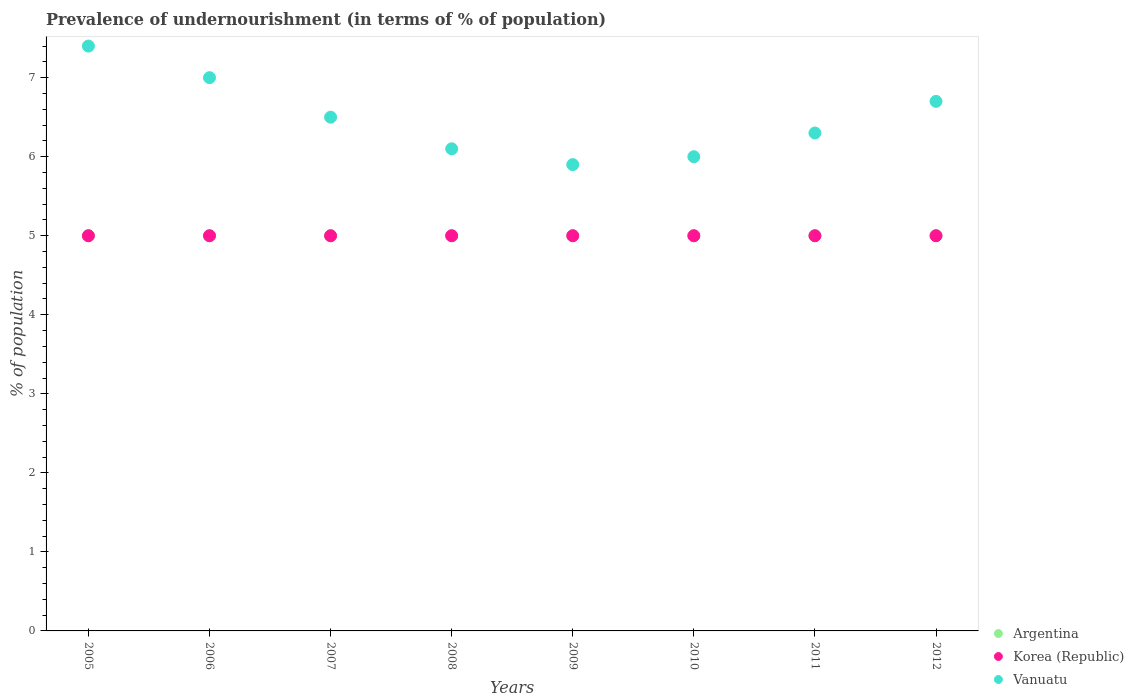How many different coloured dotlines are there?
Keep it short and to the point. 3. What is the percentage of undernourished population in Korea (Republic) in 2008?
Provide a short and direct response. 5. Across all years, what is the maximum percentage of undernourished population in Vanuatu?
Ensure brevity in your answer.  7.4. Across all years, what is the minimum percentage of undernourished population in Korea (Republic)?
Offer a very short reply. 5. In which year was the percentage of undernourished population in Argentina maximum?
Provide a short and direct response. 2005. What is the total percentage of undernourished population in Korea (Republic) in the graph?
Provide a short and direct response. 40. What is the difference between the percentage of undernourished population in Korea (Republic) in 2008 and that in 2012?
Give a very brief answer. 0. What is the difference between the percentage of undernourished population in Argentina in 2006 and the percentage of undernourished population in Vanuatu in 2011?
Keep it short and to the point. -1.3. What is the average percentage of undernourished population in Vanuatu per year?
Your answer should be very brief. 6.49. In the year 2005, what is the difference between the percentage of undernourished population in Vanuatu and percentage of undernourished population in Argentina?
Your response must be concise. 2.4. In how many years, is the percentage of undernourished population in Argentina greater than 5.4 %?
Your answer should be very brief. 0. What is the ratio of the percentage of undernourished population in Vanuatu in 2006 to that in 2011?
Provide a short and direct response. 1.11. Is the percentage of undernourished population in Vanuatu in 2008 less than that in 2009?
Provide a short and direct response. No. Is the difference between the percentage of undernourished population in Vanuatu in 2006 and 2007 greater than the difference between the percentage of undernourished population in Argentina in 2006 and 2007?
Your answer should be compact. Yes. What is the difference between the highest and the second highest percentage of undernourished population in Vanuatu?
Offer a very short reply. 0.4. In how many years, is the percentage of undernourished population in Vanuatu greater than the average percentage of undernourished population in Vanuatu taken over all years?
Your answer should be compact. 4. Is the sum of the percentage of undernourished population in Korea (Republic) in 2006 and 2007 greater than the maximum percentage of undernourished population in Vanuatu across all years?
Make the answer very short. Yes. Is it the case that in every year, the sum of the percentage of undernourished population in Vanuatu and percentage of undernourished population in Argentina  is greater than the percentage of undernourished population in Korea (Republic)?
Provide a short and direct response. Yes. Is the percentage of undernourished population in Argentina strictly greater than the percentage of undernourished population in Vanuatu over the years?
Ensure brevity in your answer.  No. How many years are there in the graph?
Make the answer very short. 8. Where does the legend appear in the graph?
Make the answer very short. Bottom right. How many legend labels are there?
Your answer should be compact. 3. How are the legend labels stacked?
Ensure brevity in your answer.  Vertical. What is the title of the graph?
Offer a terse response. Prevalence of undernourishment (in terms of % of population). What is the label or title of the Y-axis?
Provide a succinct answer. % of population. What is the % of population of Vanuatu in 2005?
Provide a succinct answer. 7.4. What is the % of population in Argentina in 2006?
Your answer should be compact. 5. What is the % of population of Korea (Republic) in 2006?
Give a very brief answer. 5. What is the % of population in Argentina in 2007?
Provide a succinct answer. 5. What is the % of population in Korea (Republic) in 2007?
Offer a very short reply. 5. What is the % of population of Argentina in 2008?
Give a very brief answer. 5. What is the % of population of Korea (Republic) in 2008?
Offer a terse response. 5. What is the % of population of Vanuatu in 2008?
Offer a very short reply. 6.1. What is the % of population in Vanuatu in 2009?
Offer a terse response. 5.9. What is the % of population in Argentina in 2010?
Your answer should be compact. 5. What is the % of population of Korea (Republic) in 2011?
Offer a very short reply. 5. Across all years, what is the maximum % of population of Korea (Republic)?
Your answer should be compact. 5. What is the total % of population of Korea (Republic) in the graph?
Provide a short and direct response. 40. What is the total % of population of Vanuatu in the graph?
Give a very brief answer. 51.9. What is the difference between the % of population of Korea (Republic) in 2005 and that in 2006?
Provide a short and direct response. 0. What is the difference between the % of population in Korea (Republic) in 2005 and that in 2008?
Your answer should be compact. 0. What is the difference between the % of population of Vanuatu in 2005 and that in 2008?
Your answer should be compact. 1.3. What is the difference between the % of population in Argentina in 2005 and that in 2009?
Offer a terse response. 0. What is the difference between the % of population in Korea (Republic) in 2005 and that in 2010?
Your answer should be very brief. 0. What is the difference between the % of population of Vanuatu in 2005 and that in 2010?
Offer a very short reply. 1.4. What is the difference between the % of population of Argentina in 2005 and that in 2011?
Ensure brevity in your answer.  0. What is the difference between the % of population in Korea (Republic) in 2005 and that in 2011?
Provide a succinct answer. 0. What is the difference between the % of population of Vanuatu in 2005 and that in 2011?
Your answer should be compact. 1.1. What is the difference between the % of population of Korea (Republic) in 2005 and that in 2012?
Your answer should be compact. 0. What is the difference between the % of population in Vanuatu in 2005 and that in 2012?
Your response must be concise. 0.7. What is the difference between the % of population in Argentina in 2006 and that in 2007?
Your answer should be compact. 0. What is the difference between the % of population of Korea (Republic) in 2006 and that in 2007?
Offer a very short reply. 0. What is the difference between the % of population in Vanuatu in 2006 and that in 2009?
Offer a very short reply. 1.1. What is the difference between the % of population of Argentina in 2006 and that in 2010?
Make the answer very short. 0. What is the difference between the % of population in Argentina in 2006 and that in 2011?
Make the answer very short. 0. What is the difference between the % of population in Vanuatu in 2006 and that in 2011?
Give a very brief answer. 0.7. What is the difference between the % of population of Argentina in 2006 and that in 2012?
Your response must be concise. 0. What is the difference between the % of population in Vanuatu in 2006 and that in 2012?
Offer a very short reply. 0.3. What is the difference between the % of population of Argentina in 2007 and that in 2009?
Give a very brief answer. 0. What is the difference between the % of population of Vanuatu in 2007 and that in 2009?
Give a very brief answer. 0.6. What is the difference between the % of population of Korea (Republic) in 2007 and that in 2010?
Provide a short and direct response. 0. What is the difference between the % of population in Vanuatu in 2007 and that in 2010?
Provide a short and direct response. 0.5. What is the difference between the % of population in Argentina in 2007 and that in 2011?
Make the answer very short. 0. What is the difference between the % of population in Korea (Republic) in 2007 and that in 2011?
Your answer should be compact. 0. What is the difference between the % of population of Korea (Republic) in 2007 and that in 2012?
Make the answer very short. 0. What is the difference between the % of population of Vanuatu in 2007 and that in 2012?
Offer a terse response. -0.2. What is the difference between the % of population in Argentina in 2008 and that in 2009?
Keep it short and to the point. 0. What is the difference between the % of population in Vanuatu in 2008 and that in 2009?
Ensure brevity in your answer.  0.2. What is the difference between the % of population in Argentina in 2008 and that in 2010?
Make the answer very short. 0. What is the difference between the % of population in Vanuatu in 2008 and that in 2010?
Keep it short and to the point. 0.1. What is the difference between the % of population in Korea (Republic) in 2008 and that in 2011?
Give a very brief answer. 0. What is the difference between the % of population of Vanuatu in 2008 and that in 2011?
Your response must be concise. -0.2. What is the difference between the % of population of Argentina in 2008 and that in 2012?
Offer a very short reply. 0. What is the difference between the % of population of Korea (Republic) in 2008 and that in 2012?
Give a very brief answer. 0. What is the difference between the % of population of Korea (Republic) in 2009 and that in 2010?
Give a very brief answer. 0. What is the difference between the % of population of Vanuatu in 2009 and that in 2011?
Provide a short and direct response. -0.4. What is the difference between the % of population in Argentina in 2009 and that in 2012?
Your answer should be very brief. 0. What is the difference between the % of population of Vanuatu in 2009 and that in 2012?
Ensure brevity in your answer.  -0.8. What is the difference between the % of population in Vanuatu in 2010 and that in 2011?
Make the answer very short. -0.3. What is the difference between the % of population in Argentina in 2010 and that in 2012?
Provide a succinct answer. 0. What is the difference between the % of population in Korea (Republic) in 2010 and that in 2012?
Offer a very short reply. 0. What is the difference between the % of population of Vanuatu in 2010 and that in 2012?
Keep it short and to the point. -0.7. What is the difference between the % of population of Vanuatu in 2011 and that in 2012?
Your answer should be very brief. -0.4. What is the difference between the % of population in Argentina in 2005 and the % of population in Vanuatu in 2006?
Your answer should be very brief. -2. What is the difference between the % of population of Argentina in 2005 and the % of population of Korea (Republic) in 2007?
Offer a terse response. 0. What is the difference between the % of population in Argentina in 2005 and the % of population in Vanuatu in 2007?
Offer a very short reply. -1.5. What is the difference between the % of population in Korea (Republic) in 2005 and the % of population in Vanuatu in 2007?
Your response must be concise. -1.5. What is the difference between the % of population of Argentina in 2005 and the % of population of Korea (Republic) in 2008?
Ensure brevity in your answer.  0. What is the difference between the % of population in Argentina in 2005 and the % of population in Vanuatu in 2008?
Your answer should be compact. -1.1. What is the difference between the % of population in Argentina in 2005 and the % of population in Vanuatu in 2009?
Offer a terse response. -0.9. What is the difference between the % of population in Argentina in 2005 and the % of population in Korea (Republic) in 2010?
Ensure brevity in your answer.  0. What is the difference between the % of population of Argentina in 2005 and the % of population of Vanuatu in 2010?
Provide a succinct answer. -1. What is the difference between the % of population of Argentina in 2005 and the % of population of Korea (Republic) in 2011?
Give a very brief answer. 0. What is the difference between the % of population in Argentina in 2005 and the % of population in Vanuatu in 2011?
Offer a very short reply. -1.3. What is the difference between the % of population in Korea (Republic) in 2005 and the % of population in Vanuatu in 2011?
Your response must be concise. -1.3. What is the difference between the % of population in Argentina in 2005 and the % of population in Korea (Republic) in 2012?
Provide a succinct answer. 0. What is the difference between the % of population of Argentina in 2005 and the % of population of Vanuatu in 2012?
Your response must be concise. -1.7. What is the difference between the % of population in Korea (Republic) in 2005 and the % of population in Vanuatu in 2012?
Your answer should be very brief. -1.7. What is the difference between the % of population of Argentina in 2006 and the % of population of Vanuatu in 2008?
Offer a very short reply. -1.1. What is the difference between the % of population of Argentina in 2006 and the % of population of Vanuatu in 2009?
Give a very brief answer. -0.9. What is the difference between the % of population in Korea (Republic) in 2006 and the % of population in Vanuatu in 2009?
Ensure brevity in your answer.  -0.9. What is the difference between the % of population of Argentina in 2006 and the % of population of Korea (Republic) in 2010?
Your answer should be compact. 0. What is the difference between the % of population in Argentina in 2006 and the % of population in Vanuatu in 2010?
Give a very brief answer. -1. What is the difference between the % of population in Argentina in 2006 and the % of population in Korea (Republic) in 2011?
Offer a very short reply. 0. What is the difference between the % of population in Korea (Republic) in 2006 and the % of population in Vanuatu in 2011?
Provide a short and direct response. -1.3. What is the difference between the % of population of Argentina in 2006 and the % of population of Korea (Republic) in 2012?
Offer a very short reply. 0. What is the difference between the % of population in Korea (Republic) in 2006 and the % of population in Vanuatu in 2012?
Offer a very short reply. -1.7. What is the difference between the % of population in Argentina in 2007 and the % of population in Korea (Republic) in 2008?
Offer a terse response. 0. What is the difference between the % of population of Korea (Republic) in 2007 and the % of population of Vanuatu in 2008?
Offer a terse response. -1.1. What is the difference between the % of population in Argentina in 2007 and the % of population in Vanuatu in 2009?
Keep it short and to the point. -0.9. What is the difference between the % of population of Korea (Republic) in 2007 and the % of population of Vanuatu in 2009?
Ensure brevity in your answer.  -0.9. What is the difference between the % of population of Argentina in 2007 and the % of population of Korea (Republic) in 2010?
Make the answer very short. 0. What is the difference between the % of population of Argentina in 2007 and the % of population of Vanuatu in 2011?
Provide a short and direct response. -1.3. What is the difference between the % of population of Argentina in 2007 and the % of population of Korea (Republic) in 2012?
Provide a succinct answer. 0. What is the difference between the % of population of Argentina in 2008 and the % of population of Vanuatu in 2010?
Ensure brevity in your answer.  -1. What is the difference between the % of population in Argentina in 2008 and the % of population in Korea (Republic) in 2011?
Ensure brevity in your answer.  0. What is the difference between the % of population of Argentina in 2008 and the % of population of Vanuatu in 2011?
Ensure brevity in your answer.  -1.3. What is the difference between the % of population of Korea (Republic) in 2008 and the % of population of Vanuatu in 2011?
Your response must be concise. -1.3. What is the difference between the % of population in Argentina in 2008 and the % of population in Korea (Republic) in 2012?
Your answer should be compact. 0. What is the difference between the % of population of Korea (Republic) in 2008 and the % of population of Vanuatu in 2012?
Your answer should be compact. -1.7. What is the difference between the % of population of Argentina in 2009 and the % of population of Korea (Republic) in 2010?
Provide a succinct answer. 0. What is the difference between the % of population of Argentina in 2009 and the % of population of Vanuatu in 2010?
Provide a short and direct response. -1. What is the difference between the % of population of Argentina in 2009 and the % of population of Korea (Republic) in 2011?
Provide a succinct answer. 0. What is the difference between the % of population of Argentina in 2009 and the % of population of Vanuatu in 2011?
Your response must be concise. -1.3. What is the difference between the % of population in Korea (Republic) in 2009 and the % of population in Vanuatu in 2011?
Offer a terse response. -1.3. What is the difference between the % of population in Argentina in 2009 and the % of population in Korea (Republic) in 2012?
Offer a very short reply. 0. What is the difference between the % of population in Argentina in 2009 and the % of population in Vanuatu in 2012?
Provide a succinct answer. -1.7. What is the difference between the % of population in Korea (Republic) in 2009 and the % of population in Vanuatu in 2012?
Your response must be concise. -1.7. What is the difference between the % of population of Argentina in 2010 and the % of population of Korea (Republic) in 2011?
Provide a short and direct response. 0. What is the difference between the % of population in Argentina in 2010 and the % of population in Vanuatu in 2011?
Your answer should be compact. -1.3. What is the difference between the % of population in Korea (Republic) in 2010 and the % of population in Vanuatu in 2011?
Your answer should be very brief. -1.3. What is the difference between the % of population in Argentina in 2010 and the % of population in Korea (Republic) in 2012?
Your response must be concise. 0. What is the difference between the % of population in Argentina in 2011 and the % of population in Korea (Republic) in 2012?
Give a very brief answer. 0. What is the difference between the % of population in Argentina in 2011 and the % of population in Vanuatu in 2012?
Provide a short and direct response. -1.7. What is the average % of population in Korea (Republic) per year?
Make the answer very short. 5. What is the average % of population of Vanuatu per year?
Make the answer very short. 6.49. In the year 2005, what is the difference between the % of population of Argentina and % of population of Vanuatu?
Keep it short and to the point. -2.4. In the year 2005, what is the difference between the % of population in Korea (Republic) and % of population in Vanuatu?
Make the answer very short. -2.4. In the year 2007, what is the difference between the % of population of Argentina and % of population of Vanuatu?
Your answer should be compact. -1.5. In the year 2007, what is the difference between the % of population in Korea (Republic) and % of population in Vanuatu?
Provide a succinct answer. -1.5. In the year 2008, what is the difference between the % of population in Korea (Republic) and % of population in Vanuatu?
Your answer should be compact. -1.1. In the year 2009, what is the difference between the % of population in Argentina and % of population in Korea (Republic)?
Ensure brevity in your answer.  0. In the year 2010, what is the difference between the % of population in Argentina and % of population in Korea (Republic)?
Offer a terse response. 0. In the year 2010, what is the difference between the % of population in Korea (Republic) and % of population in Vanuatu?
Your answer should be compact. -1. In the year 2011, what is the difference between the % of population of Argentina and % of population of Korea (Republic)?
Offer a very short reply. 0. In the year 2011, what is the difference between the % of population of Korea (Republic) and % of population of Vanuatu?
Give a very brief answer. -1.3. What is the ratio of the % of population in Korea (Republic) in 2005 to that in 2006?
Your answer should be very brief. 1. What is the ratio of the % of population in Vanuatu in 2005 to that in 2006?
Provide a short and direct response. 1.06. What is the ratio of the % of population of Argentina in 2005 to that in 2007?
Keep it short and to the point. 1. What is the ratio of the % of population in Vanuatu in 2005 to that in 2007?
Offer a terse response. 1.14. What is the ratio of the % of population in Korea (Republic) in 2005 to that in 2008?
Your answer should be very brief. 1. What is the ratio of the % of population of Vanuatu in 2005 to that in 2008?
Provide a short and direct response. 1.21. What is the ratio of the % of population of Argentina in 2005 to that in 2009?
Your answer should be compact. 1. What is the ratio of the % of population of Korea (Republic) in 2005 to that in 2009?
Your answer should be very brief. 1. What is the ratio of the % of population in Vanuatu in 2005 to that in 2009?
Ensure brevity in your answer.  1.25. What is the ratio of the % of population in Argentina in 2005 to that in 2010?
Offer a very short reply. 1. What is the ratio of the % of population of Vanuatu in 2005 to that in 2010?
Your answer should be compact. 1.23. What is the ratio of the % of population of Korea (Republic) in 2005 to that in 2011?
Give a very brief answer. 1. What is the ratio of the % of population of Vanuatu in 2005 to that in 2011?
Provide a succinct answer. 1.17. What is the ratio of the % of population of Vanuatu in 2005 to that in 2012?
Offer a terse response. 1.1. What is the ratio of the % of population in Argentina in 2006 to that in 2007?
Your answer should be compact. 1. What is the ratio of the % of population in Korea (Republic) in 2006 to that in 2007?
Give a very brief answer. 1. What is the ratio of the % of population in Vanuatu in 2006 to that in 2007?
Offer a very short reply. 1.08. What is the ratio of the % of population of Korea (Republic) in 2006 to that in 2008?
Give a very brief answer. 1. What is the ratio of the % of population of Vanuatu in 2006 to that in 2008?
Provide a short and direct response. 1.15. What is the ratio of the % of population in Argentina in 2006 to that in 2009?
Keep it short and to the point. 1. What is the ratio of the % of population of Korea (Republic) in 2006 to that in 2009?
Keep it short and to the point. 1. What is the ratio of the % of population of Vanuatu in 2006 to that in 2009?
Your answer should be very brief. 1.19. What is the ratio of the % of population of Argentina in 2006 to that in 2010?
Your answer should be compact. 1. What is the ratio of the % of population of Korea (Republic) in 2006 to that in 2010?
Offer a very short reply. 1. What is the ratio of the % of population of Vanuatu in 2006 to that in 2010?
Provide a succinct answer. 1.17. What is the ratio of the % of population in Vanuatu in 2006 to that in 2011?
Make the answer very short. 1.11. What is the ratio of the % of population of Korea (Republic) in 2006 to that in 2012?
Your response must be concise. 1. What is the ratio of the % of population of Vanuatu in 2006 to that in 2012?
Provide a short and direct response. 1.04. What is the ratio of the % of population of Korea (Republic) in 2007 to that in 2008?
Offer a terse response. 1. What is the ratio of the % of population of Vanuatu in 2007 to that in 2008?
Ensure brevity in your answer.  1.07. What is the ratio of the % of population of Korea (Republic) in 2007 to that in 2009?
Offer a terse response. 1. What is the ratio of the % of population in Vanuatu in 2007 to that in 2009?
Ensure brevity in your answer.  1.1. What is the ratio of the % of population of Argentina in 2007 to that in 2010?
Your answer should be compact. 1. What is the ratio of the % of population in Korea (Republic) in 2007 to that in 2010?
Offer a very short reply. 1. What is the ratio of the % of population in Argentina in 2007 to that in 2011?
Give a very brief answer. 1. What is the ratio of the % of population in Korea (Republic) in 2007 to that in 2011?
Your response must be concise. 1. What is the ratio of the % of population of Vanuatu in 2007 to that in 2011?
Provide a succinct answer. 1.03. What is the ratio of the % of population in Vanuatu in 2007 to that in 2012?
Your answer should be compact. 0.97. What is the ratio of the % of population of Vanuatu in 2008 to that in 2009?
Your response must be concise. 1.03. What is the ratio of the % of population of Vanuatu in 2008 to that in 2010?
Provide a short and direct response. 1.02. What is the ratio of the % of population of Korea (Republic) in 2008 to that in 2011?
Your answer should be very brief. 1. What is the ratio of the % of population in Vanuatu in 2008 to that in 2011?
Offer a terse response. 0.97. What is the ratio of the % of population in Argentina in 2008 to that in 2012?
Your answer should be very brief. 1. What is the ratio of the % of population of Vanuatu in 2008 to that in 2012?
Your answer should be very brief. 0.91. What is the ratio of the % of population in Vanuatu in 2009 to that in 2010?
Make the answer very short. 0.98. What is the ratio of the % of population in Vanuatu in 2009 to that in 2011?
Ensure brevity in your answer.  0.94. What is the ratio of the % of population in Argentina in 2009 to that in 2012?
Your response must be concise. 1. What is the ratio of the % of population of Korea (Republic) in 2009 to that in 2012?
Make the answer very short. 1. What is the ratio of the % of population of Vanuatu in 2009 to that in 2012?
Provide a succinct answer. 0.88. What is the ratio of the % of population of Argentina in 2010 to that in 2011?
Your answer should be very brief. 1. What is the ratio of the % of population in Korea (Republic) in 2010 to that in 2011?
Ensure brevity in your answer.  1. What is the ratio of the % of population in Korea (Republic) in 2010 to that in 2012?
Offer a very short reply. 1. What is the ratio of the % of population of Vanuatu in 2010 to that in 2012?
Keep it short and to the point. 0.9. What is the ratio of the % of population in Argentina in 2011 to that in 2012?
Your answer should be very brief. 1. What is the ratio of the % of population of Korea (Republic) in 2011 to that in 2012?
Keep it short and to the point. 1. What is the ratio of the % of population of Vanuatu in 2011 to that in 2012?
Your answer should be compact. 0.94. What is the difference between the highest and the second highest % of population in Argentina?
Provide a short and direct response. 0. What is the difference between the highest and the second highest % of population of Vanuatu?
Keep it short and to the point. 0.4. What is the difference between the highest and the lowest % of population in Argentina?
Keep it short and to the point. 0. What is the difference between the highest and the lowest % of population of Vanuatu?
Ensure brevity in your answer.  1.5. 